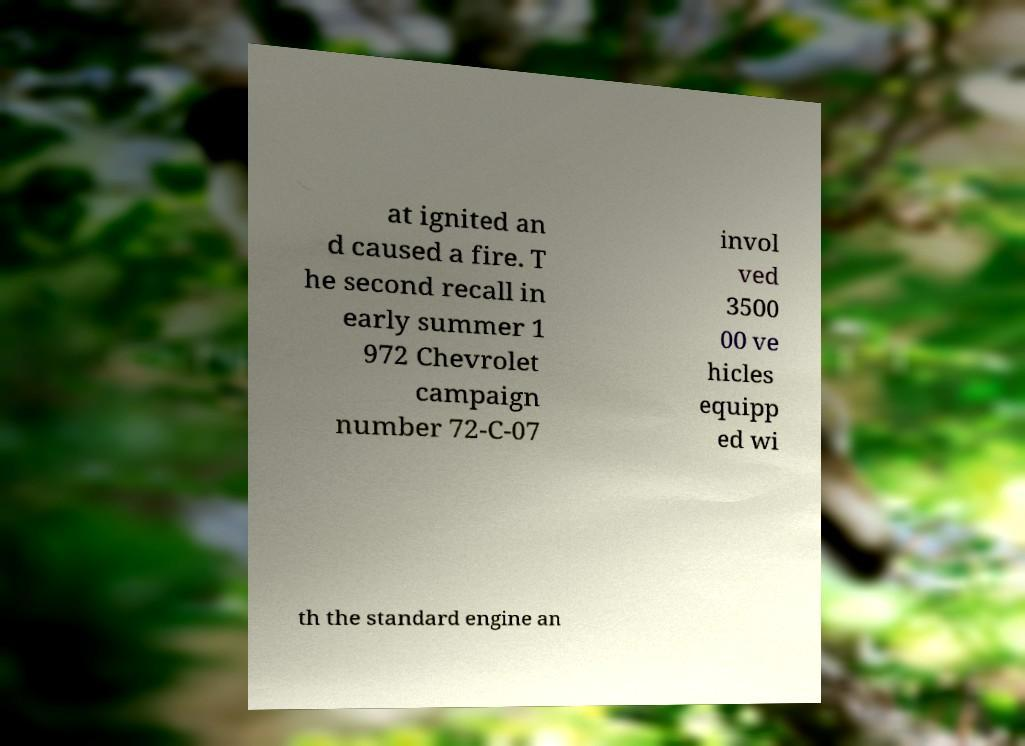Could you assist in decoding the text presented in this image and type it out clearly? at ignited an d caused a fire. T he second recall in early summer 1 972 Chevrolet campaign number 72-C-07 invol ved 3500 00 ve hicles equipp ed wi th the standard engine an 